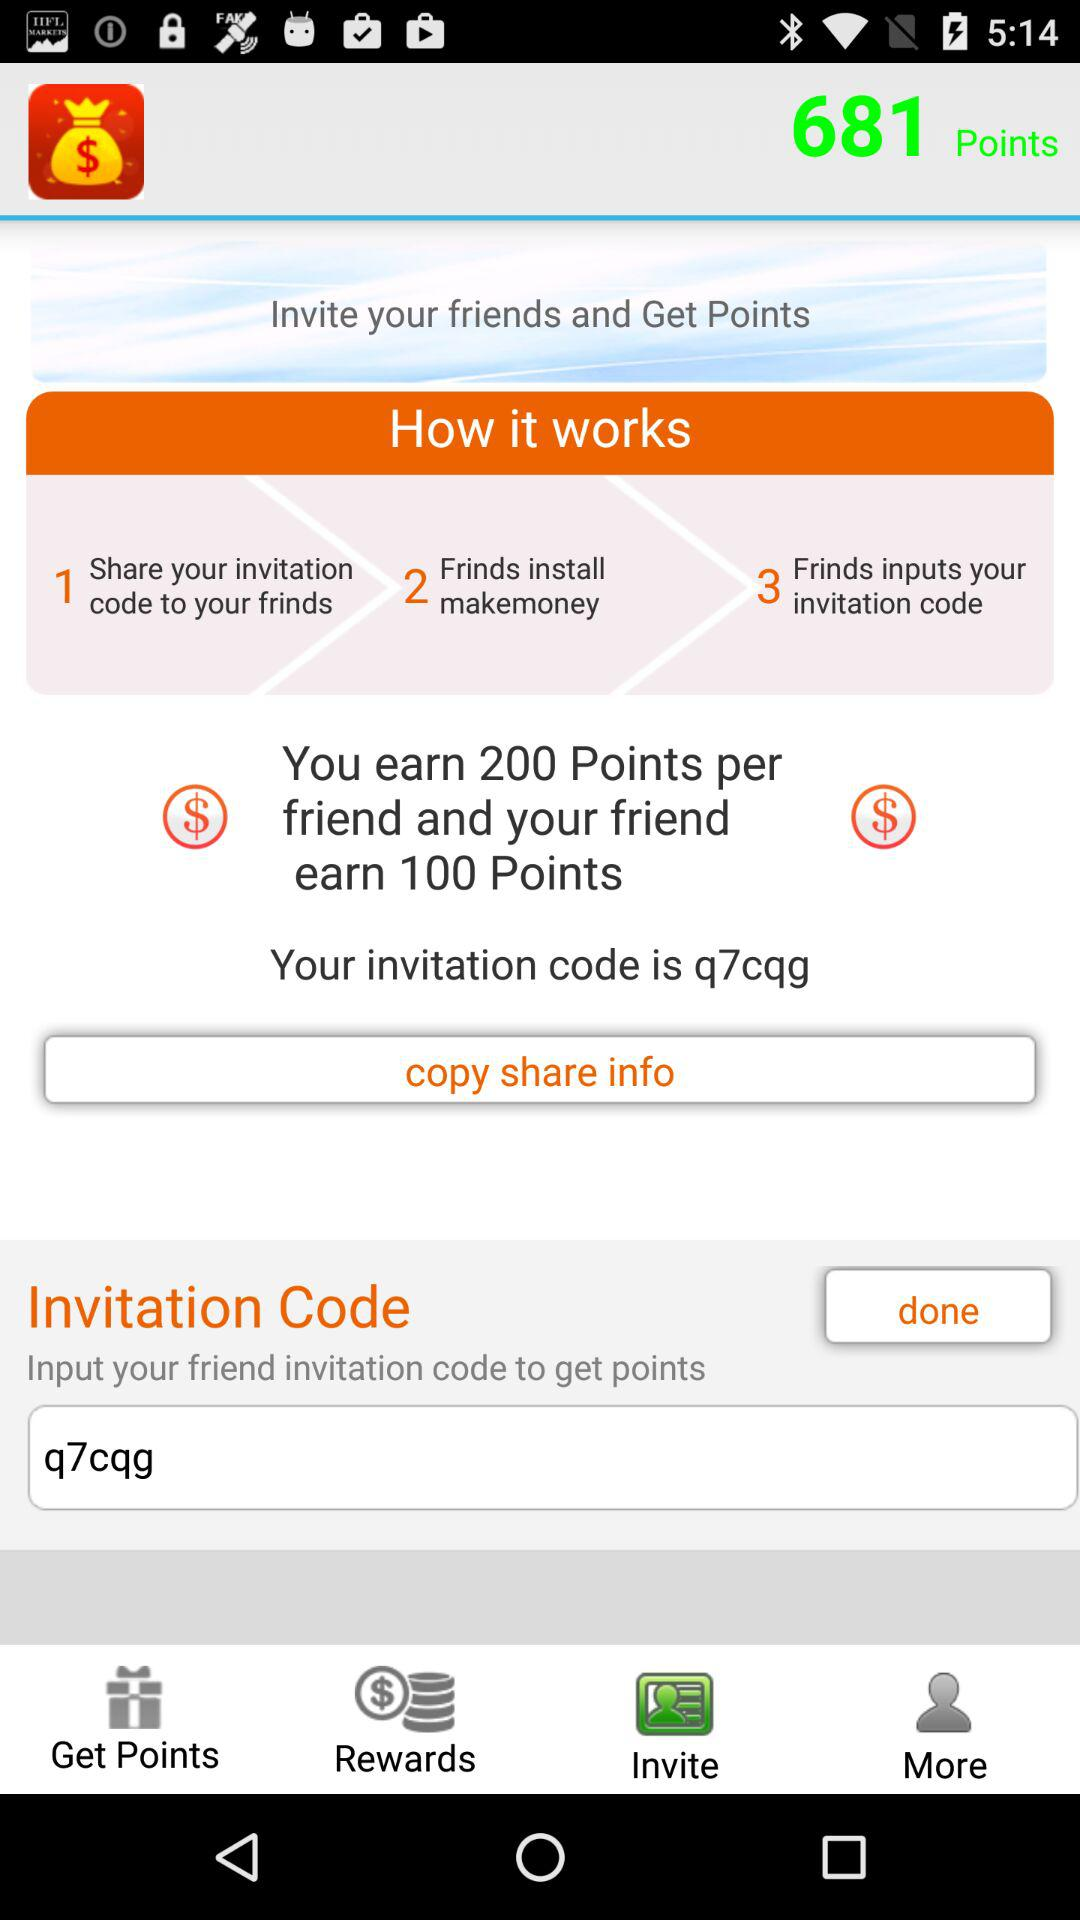How to earn points? To earn points, invite your friends. 